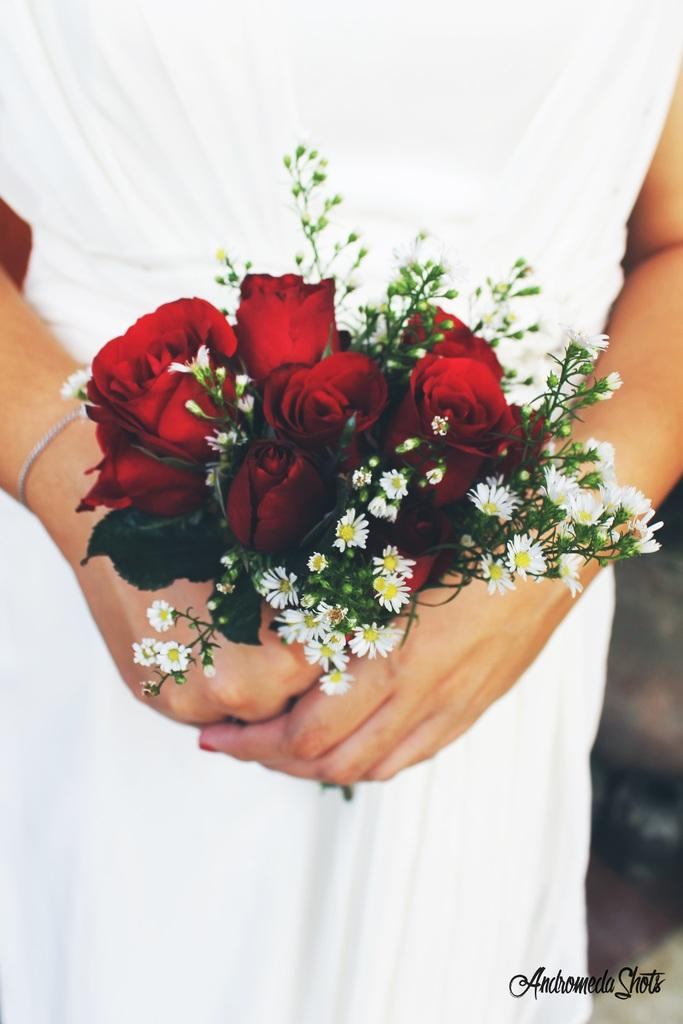What is the person in the image holding? The person is holding a flower bouquet. Can you describe the background of the image? There is a blurred view on the right side bottom of the image. Is there any text or logo visible in the image? Yes, there is a watermark in the image. How many frogs can be seen in the image? There are no frogs present in the image. What type of holiday is being celebrated in the image? The image does not depict any specific holiday. 